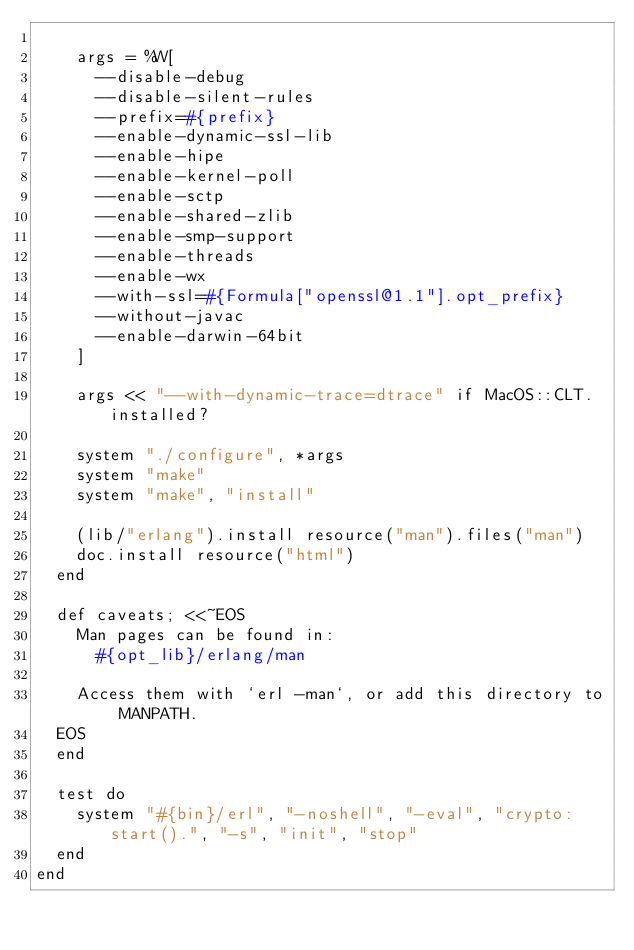<code> <loc_0><loc_0><loc_500><loc_500><_Ruby_>
    args = %W[
      --disable-debug
      --disable-silent-rules
      --prefix=#{prefix}
      --enable-dynamic-ssl-lib
      --enable-hipe
      --enable-kernel-poll
      --enable-sctp
      --enable-shared-zlib
      --enable-smp-support
      --enable-threads
      --enable-wx
      --with-ssl=#{Formula["openssl@1.1"].opt_prefix}
      --without-javac
      --enable-darwin-64bit
    ]

    args << "--with-dynamic-trace=dtrace" if MacOS::CLT.installed?

    system "./configure", *args
    system "make"
    system "make", "install"

    (lib/"erlang").install resource("man").files("man")
    doc.install resource("html")
  end

  def caveats; <<~EOS
    Man pages can be found in:
      #{opt_lib}/erlang/man

    Access them with `erl -man`, or add this directory to MANPATH.
  EOS
  end

  test do
    system "#{bin}/erl", "-noshell", "-eval", "crypto:start().", "-s", "init", "stop"
  end
end
</code> 